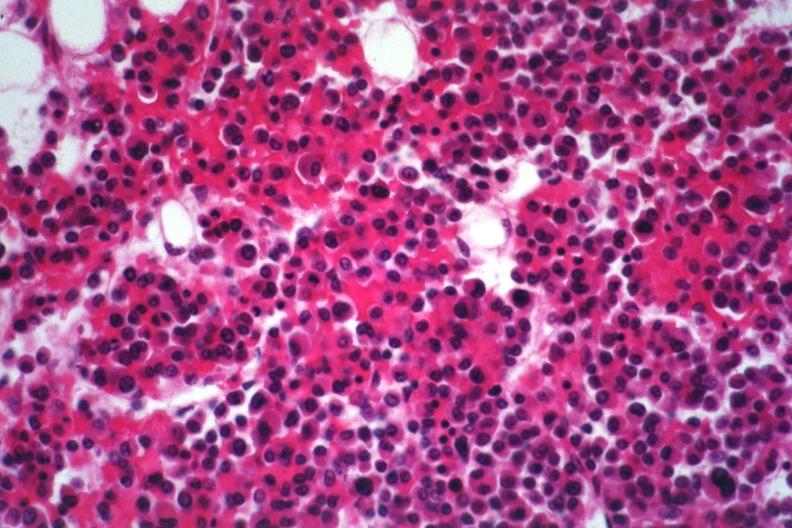s multiple myeloma present?
Answer the question using a single word or phrase. Yes 